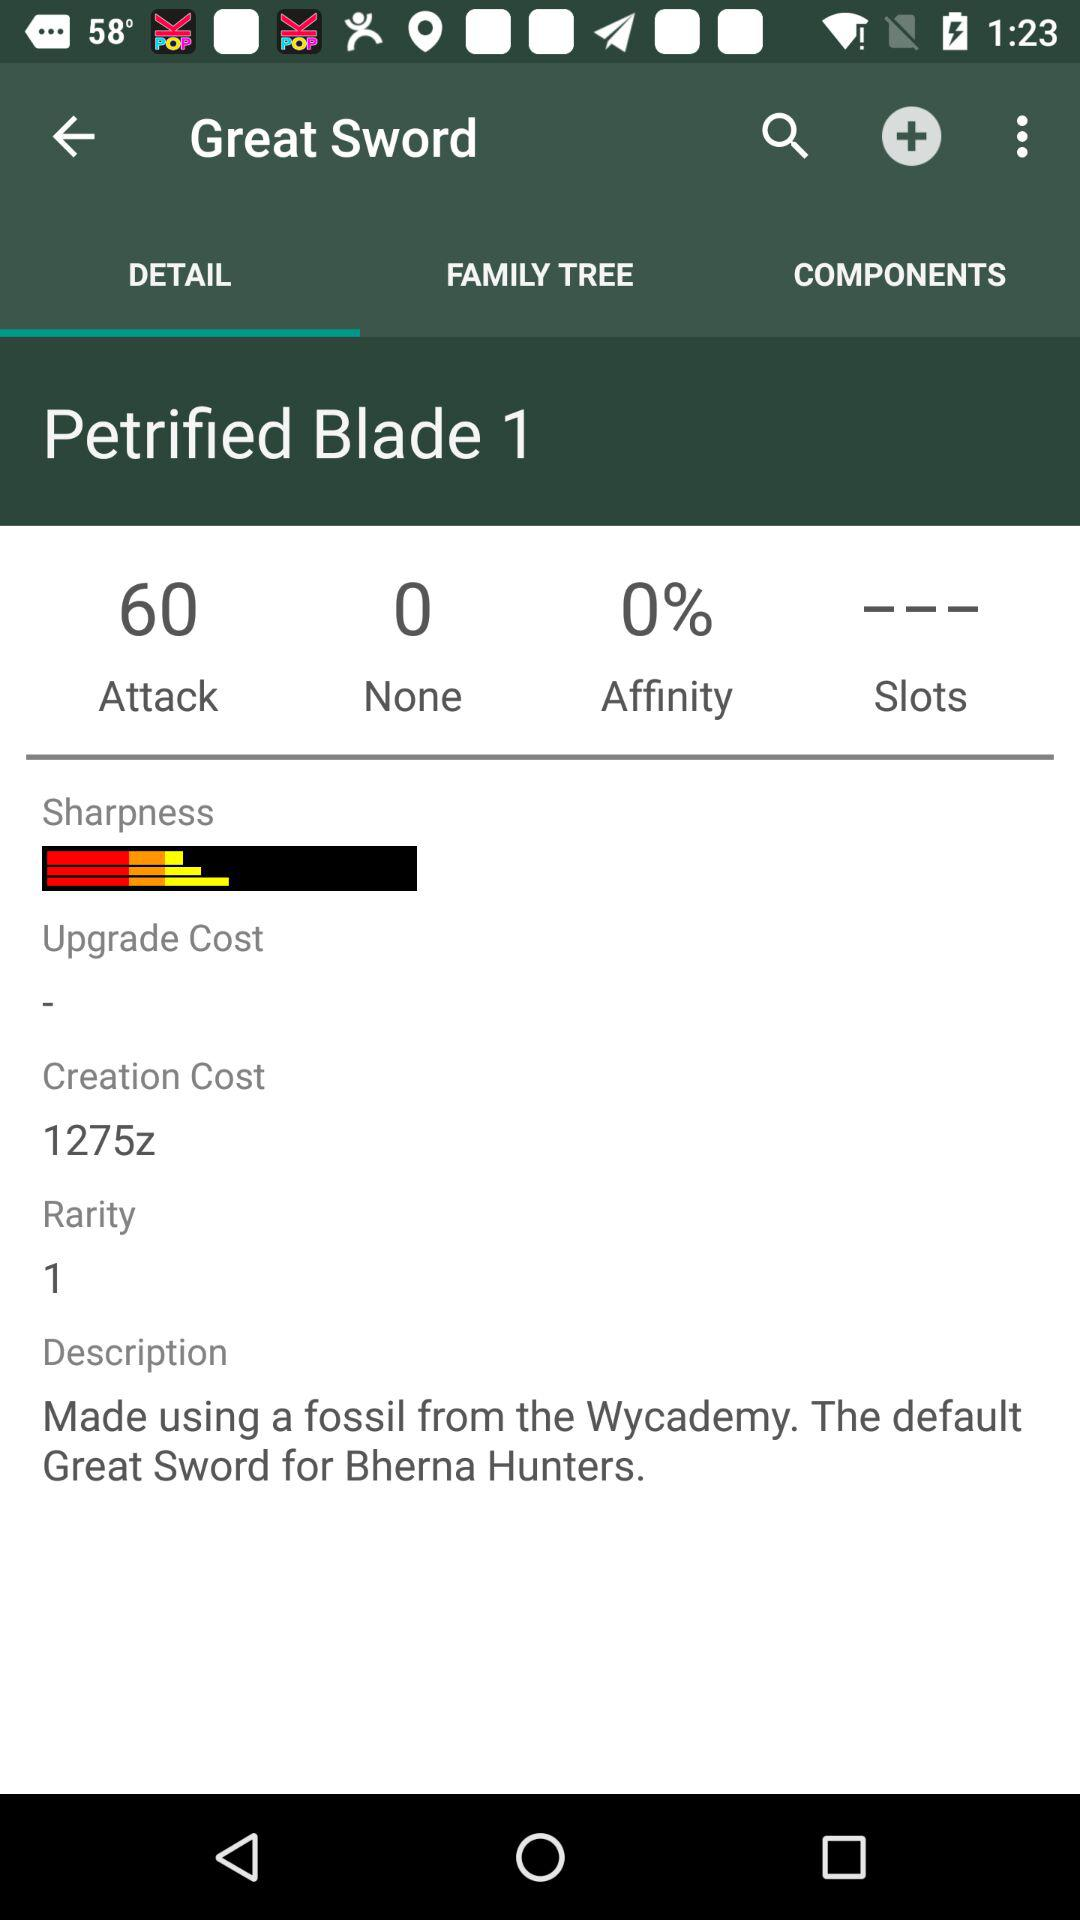For whom is the great sword designed? The great sword is designed for Bherna hunters. 